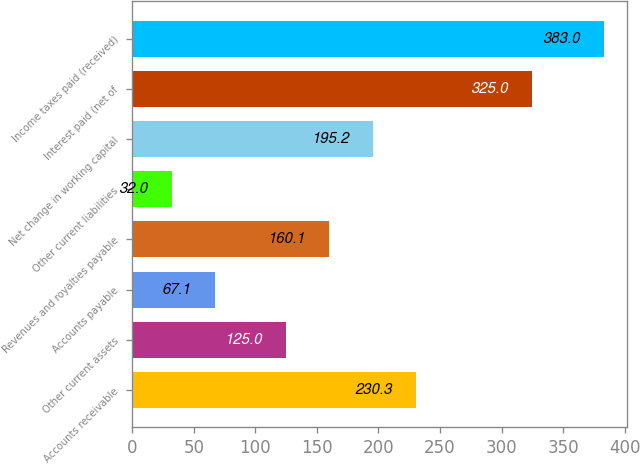Convert chart. <chart><loc_0><loc_0><loc_500><loc_500><bar_chart><fcel>Accounts receivable<fcel>Other current assets<fcel>Accounts payable<fcel>Revenues and royalties payable<fcel>Other current liabilities<fcel>Net change in working capital<fcel>Interest paid (net of<fcel>Income taxes paid (received)<nl><fcel>230.3<fcel>125<fcel>67.1<fcel>160.1<fcel>32<fcel>195.2<fcel>325<fcel>383<nl></chart> 